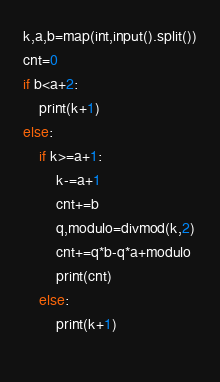Convert code to text. <code><loc_0><loc_0><loc_500><loc_500><_Python_>k,a,b=map(int,input().split())
cnt=0
if b<a+2:
    print(k+1)
else:
    if k>=a+1:
        k-=a+1
        cnt+=b
        q,modulo=divmod(k,2)
        cnt+=q*b-q*a+modulo
        print(cnt)
    else:
        print(k+1)
    </code> 